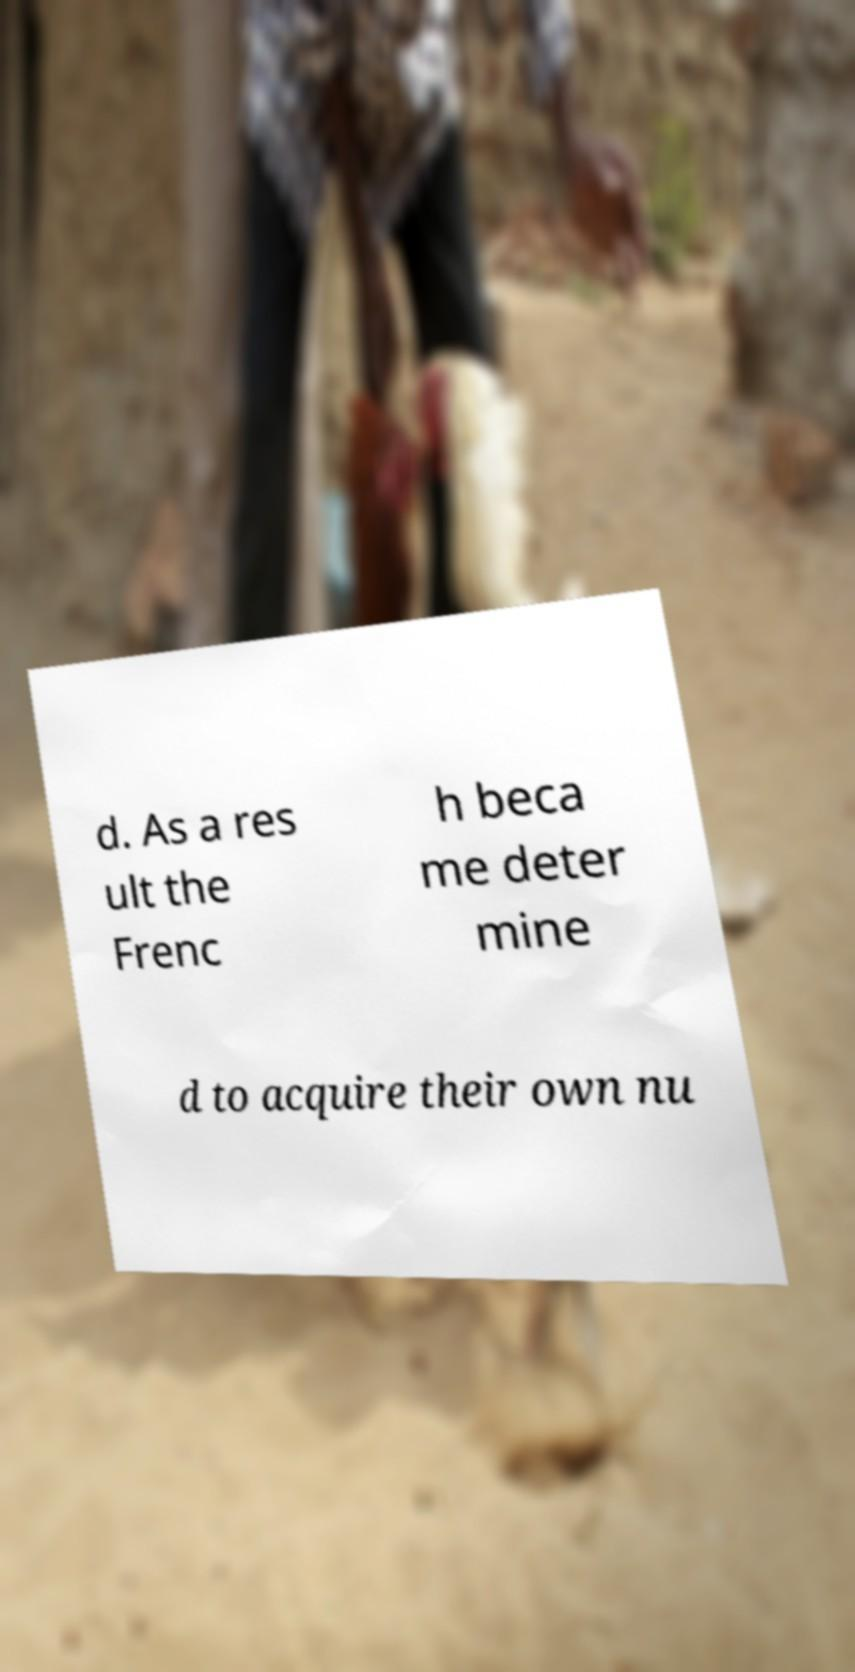Please identify and transcribe the text found in this image. d. As a res ult the Frenc h beca me deter mine d to acquire their own nu 